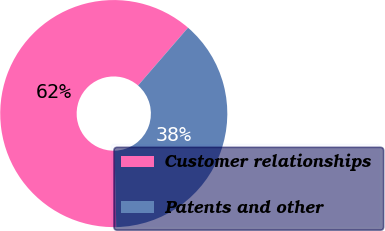Convert chart. <chart><loc_0><loc_0><loc_500><loc_500><pie_chart><fcel>Customer relationships<fcel>Patents and other<nl><fcel>61.7%<fcel>38.3%<nl></chart> 